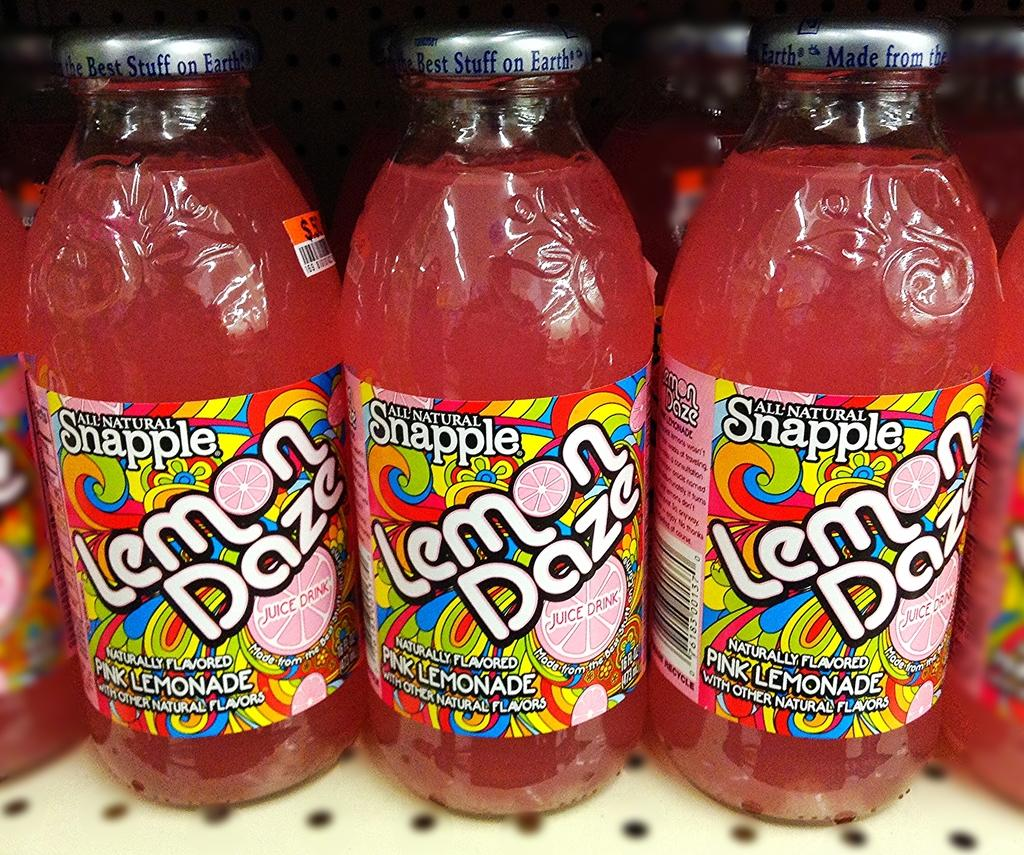<image>
Provide a brief description of the given image. Glass bottles on a shelf that says Snapple on them. 